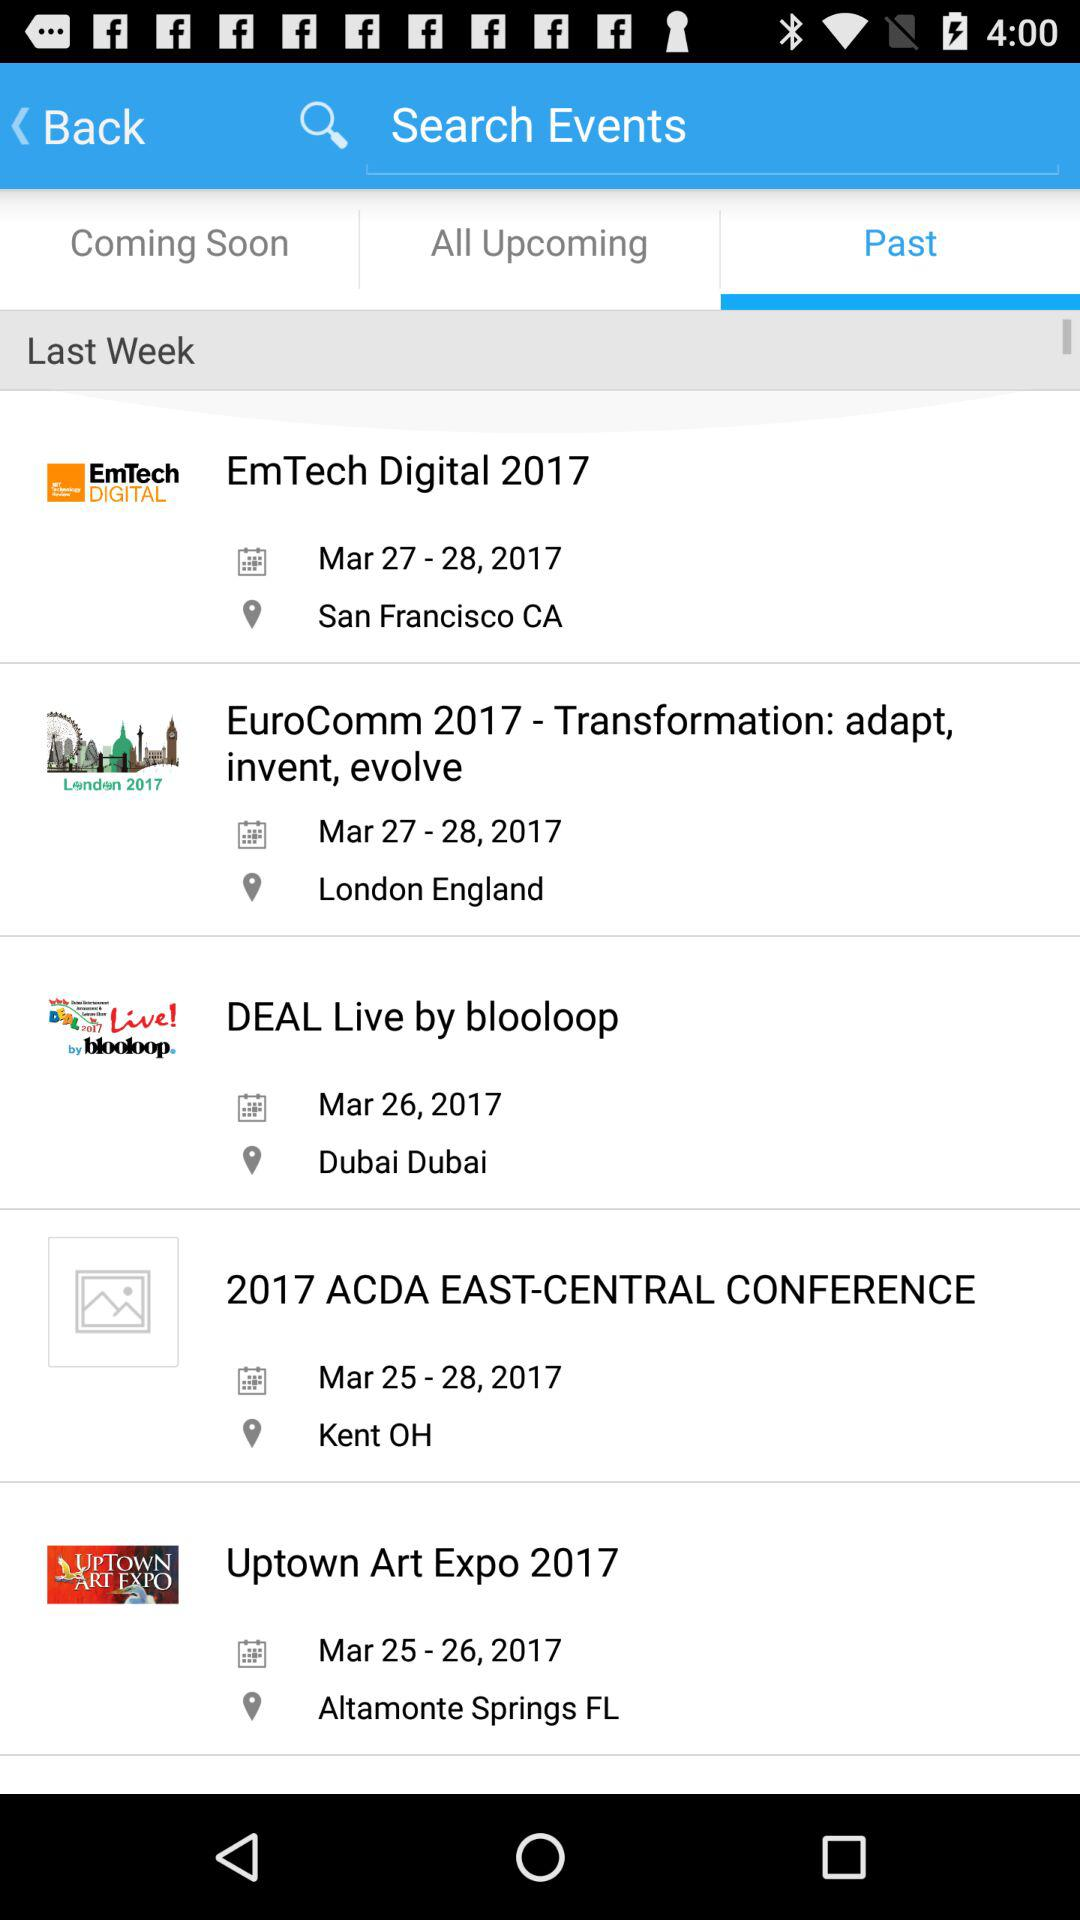How many events are in the last week category?
Answer the question using a single word or phrase. 5 